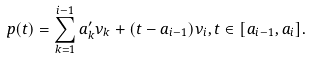<formula> <loc_0><loc_0><loc_500><loc_500>p ( t ) = \sum _ { k = 1 } ^ { i - 1 } a _ { k } ^ { \prime } \nu _ { k } + ( t - a _ { i - 1 } ) \nu _ { i } , t \in [ a _ { i - 1 } , a _ { i } ] .</formula> 